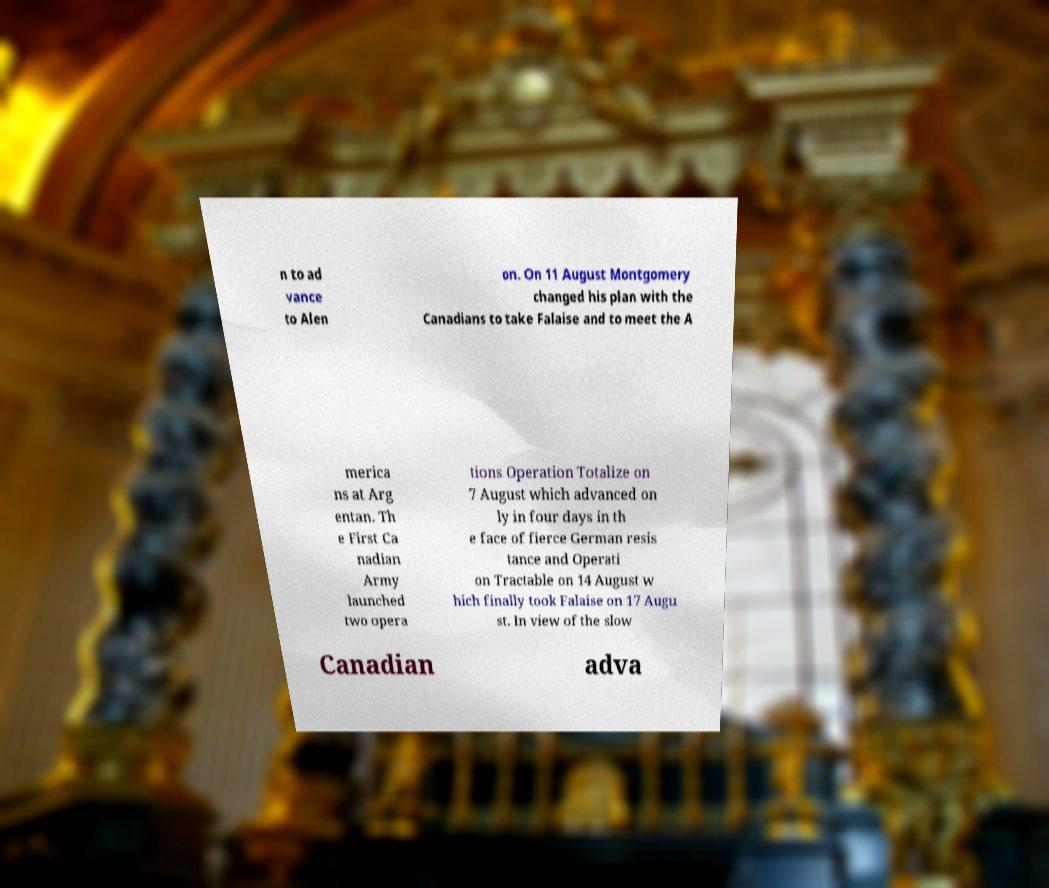Please identify and transcribe the text found in this image. n to ad vance to Alen on. On 11 August Montgomery changed his plan with the Canadians to take Falaise and to meet the A merica ns at Arg entan. Th e First Ca nadian Army launched two opera tions Operation Totalize on 7 August which advanced on ly in four days in th e face of fierce German resis tance and Operati on Tractable on 14 August w hich finally took Falaise on 17 Augu st. In view of the slow Canadian adva 